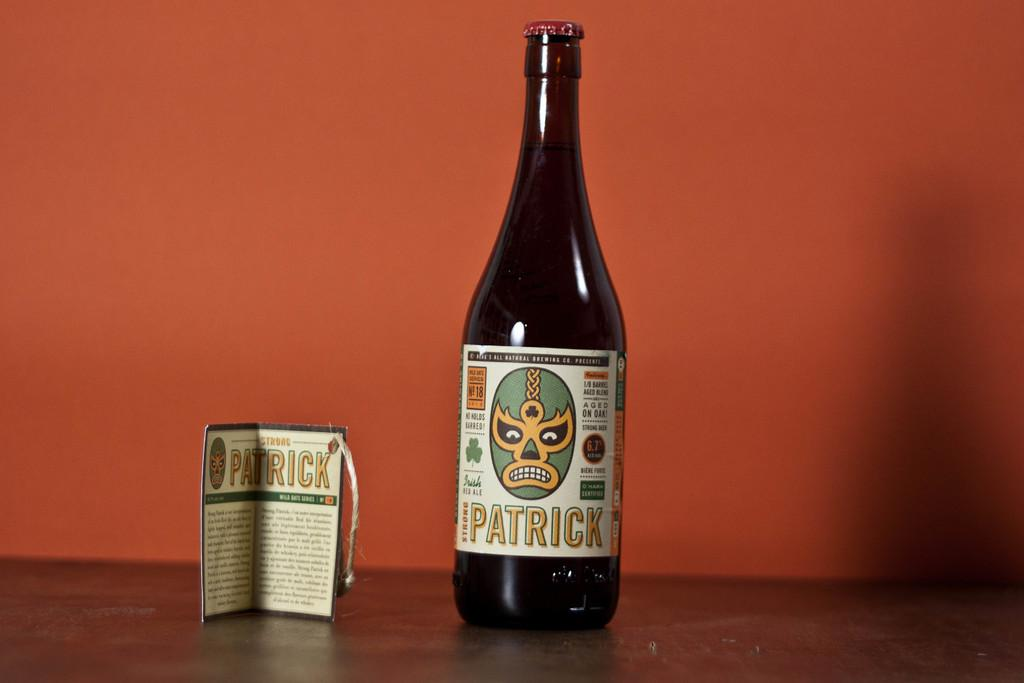<image>
Present a compact description of the photo's key features. a bottle of strong patrick standing next to a label book 